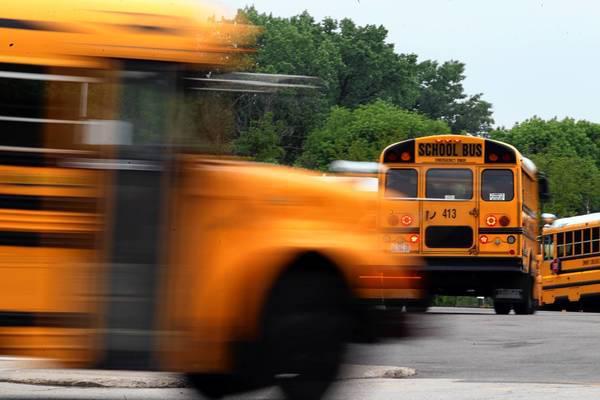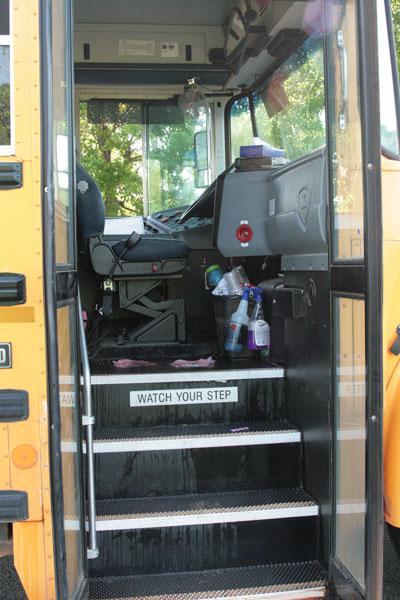The first image is the image on the left, the second image is the image on the right. Considering the images on both sides, is "An image shows an open bus door viewed head-on, with steps leading inside and the driver seat facing rightward." valid? Answer yes or no. Yes. The first image is the image on the left, the second image is the image on the right. Assess this claim about the two images: "One of the buses' passenger door is open.". Correct or not? Answer yes or no. Yes. 